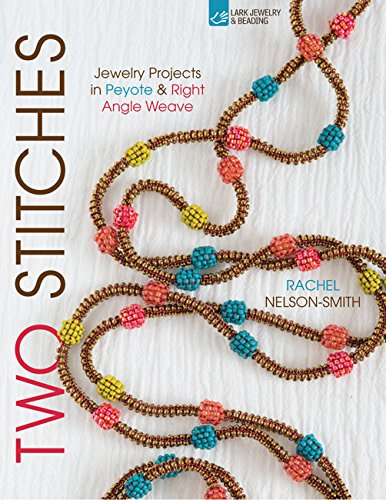What skill level is required to undertake projects in this book? The projects in 'Two Stitches' cater to various skill levels, providing options for beginners, intermediates, and advanced crafters looking to enhance their bead weaving skills. Are there any projects for complete beginners? Yes, the book includes several projects that are perfect for beginners, guiding them through basic techniques and simple designs to get started. 